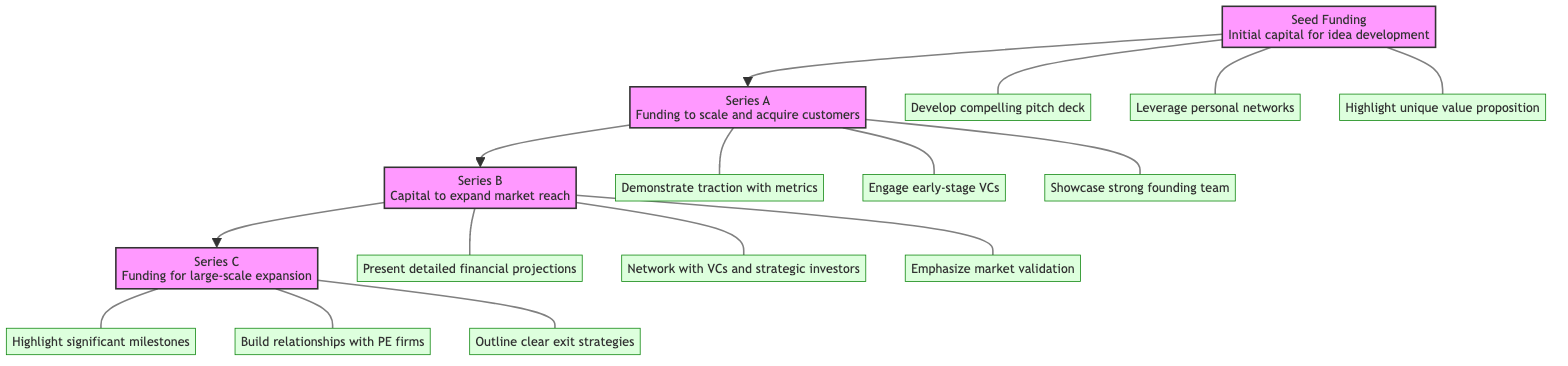What is the first funding stage shown in the diagram? The diagram begins with the Seed Funding stage at the bottom, which is the first stage in the funding hierarchy.
Answer: Seed Funding How many investor engagement techniques are listed for Series B? Under the Series B stage, there are three listed investor engagement techniques (present detailed financial projections, network with VCs, emphasize market validation).
Answer: 3 What type of investors are engaged during Series C? In the Series C stage, the engagement focuses on private equity firms and late-stage investors, which are the specific types mentioned for this stage.
Answer: Private equity firms What is the main purpose of Seed Funding? The Seed Funding stage is aimed at providing initial capital to develop an idea into a viable product or service. This description is explicitly stated in the diagram.
Answer: Initial capital to develop an idea Which stage comes just before Series A? The diagram flows upwards, showing that Seed Funding precedes Series A as the lower stage, establishing the order of funding stages.
Answer: Seed Funding What should be highlighted in the pitch for Seed Funding? The investor engagement techniques for Seed Funding emphasize the importance of highlighting the unique value proposition and potential market size, which are critical to attract initial investors.
Answer: Unique value proposition Which funding stage involves expanding market reach? The Series B stage is focused on capital to expand market reach and build out operations, as clearly described in the diagram.
Answer: Series B How many total stages are represented in the diagram? The diagram consists of four distinct stages labeled Seed Funding, Series A, Series B, and Series C, making a total of four stages.
Answer: 4 What engagement technique involves showing traction? The technique listed for Series A includes demonstrating traction with key metrics like user growth and revenue, which is essential for investors in that stage.
Answer: Demonstrate traction with key metrics What is an expected outcome of Series C funding? Series C funding aims for large-scale expansion, including entering new markets or acquiring other companies, which is specified in the diagram.
Answer: Large-scale expansion 